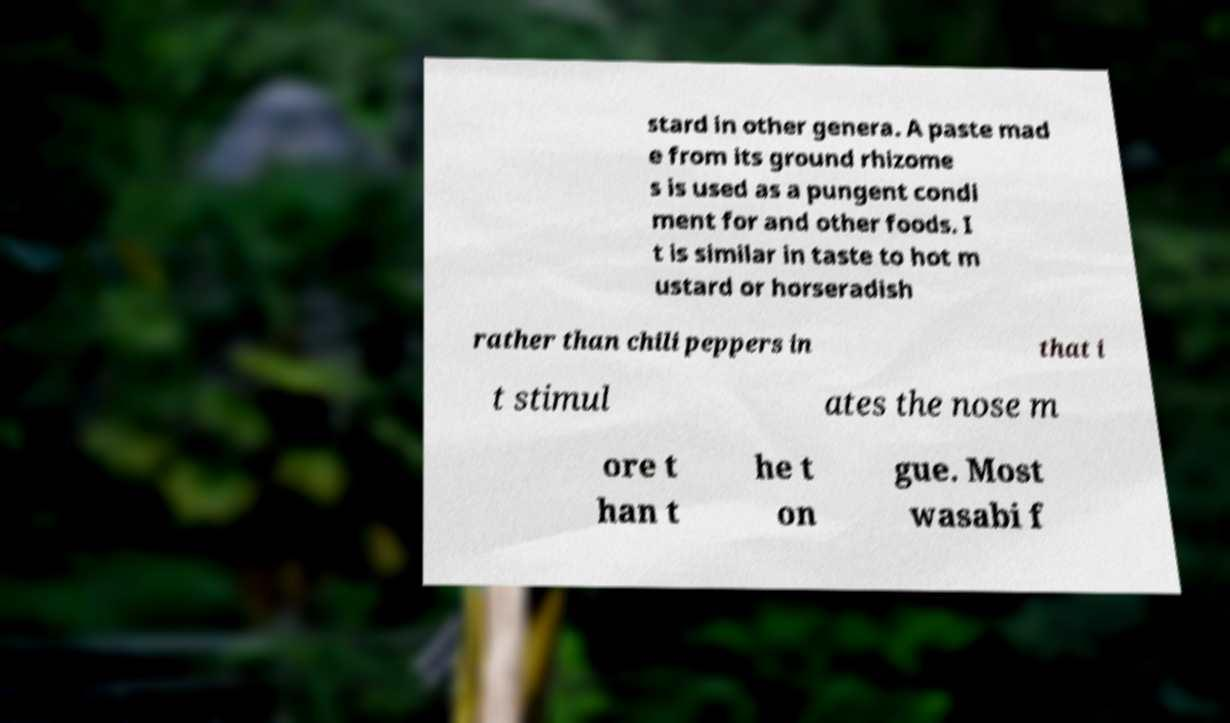Can you read and provide the text displayed in the image?This photo seems to have some interesting text. Can you extract and type it out for me? stard in other genera. A paste mad e from its ground rhizome s is used as a pungent condi ment for and other foods. I t is similar in taste to hot m ustard or horseradish rather than chili peppers in that i t stimul ates the nose m ore t han t he t on gue. Most wasabi f 